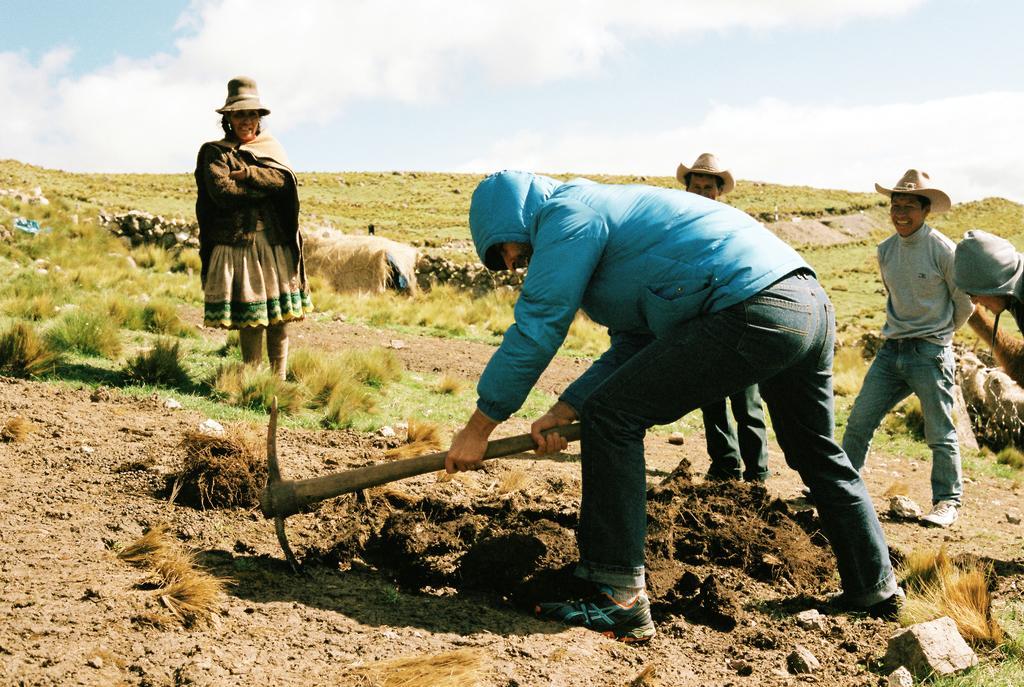How would you summarize this image in a sentence or two? In this image we can see some persons, earth excavation tool, grass and other objects. In the background of the image there is the grass and other objects. At the top of the image there is the sky. At the bottom of the image there is the ground. 